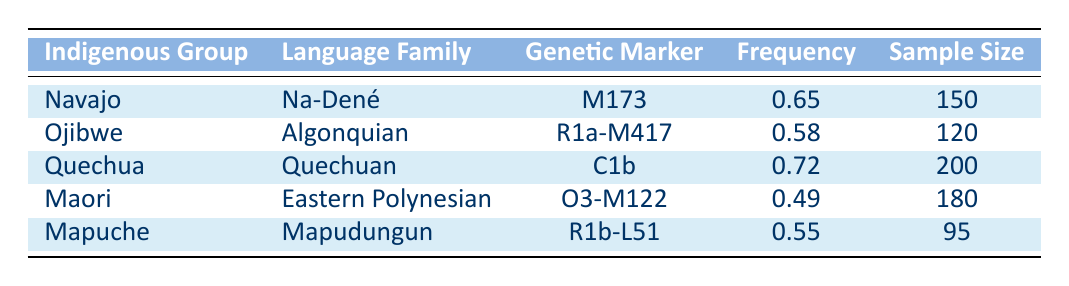What is the frequency of the genetic marker M173 in the Navajo group? The table lists the frequency of the genetic marker M173 for the Navajo group as 0.65.
Answer: 0.65 How many samples were collected from the Ojibwe group? According to the table, the sample size for the Ojibwe group is given as 120.
Answer: 120 Which indigenous group has the highest frequency of a genetic marker? By comparing the frequencies listed in the table, the Quechua group has the highest frequency of 0.72.
Answer: Quechua Is the frequency of the genetic marker O3-M122 for the Maori group greater than 0.50? The table indicates that for the Maori group, the frequency of the genetic marker O3-M122 is 0.49, which is less than 0.50. Therefore, the answer is no.
Answer: No What is the average frequency of genetic markers across all groups listed? To calculate the average, sum the frequencies (0.65 + 0.58 + 0.72 + 0.49 + 0.55 = 3.99) and divide by the number of groups (5). The average frequency is 3.99 / 5 = 0.798.
Answer: 0.798 Which two indigenous groups have the closest frequencies of their respective genetic markers? The frequencies for the Mapuche (0.55) and Ojibwe (0.58) are the closest. The difference is 0.58 - 0.55 = 0.03, which is minimal compared to the differences between other groups.
Answer: Ojibwe and Mapuche Does the Quechua group belong to the same language family as the Maori group? The Quechua group belongs to the Quechuan language family, while the Maori group belongs to the Eastern Polynesian language family. They are different.
Answer: No How many total samples were collected from all groups? The total sample size is found by adding the sample sizes (150 + 120 + 200 + 180 + 95 = 845). Therefore, the total samples collected from all groups is 845.
Answer: 845 What is the frequency difference between the genetic markers of the Navajo and the Mapuche groups? The frequency for the Navajo group is 0.65 and for the Mapuche group is 0.55. The difference is 0.65 - 0.55 = 0.10.
Answer: 0.10 Which genetic marker has the lowest frequency among the listed groups? By reviewing the frequencies, O3-M122 for the Maori group has the lowest frequency at 0.49.
Answer: O3-M122 